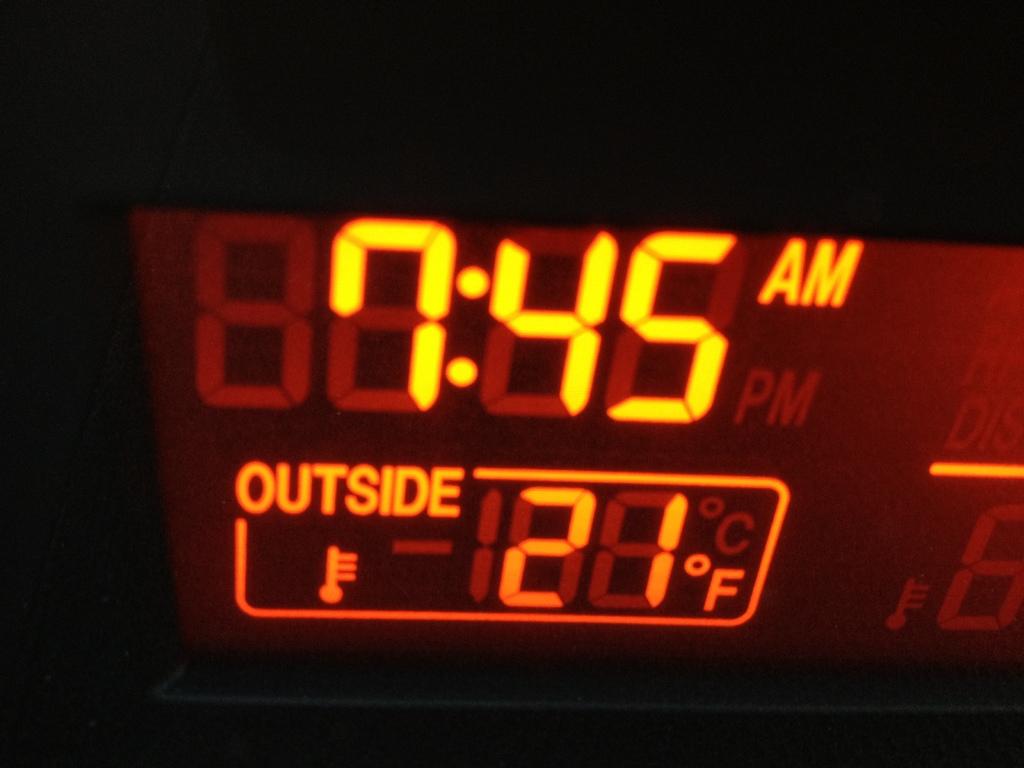What is the temperature outside ?
Offer a very short reply. 21. Is it morning or afternoon?
Your answer should be very brief. Morning. 